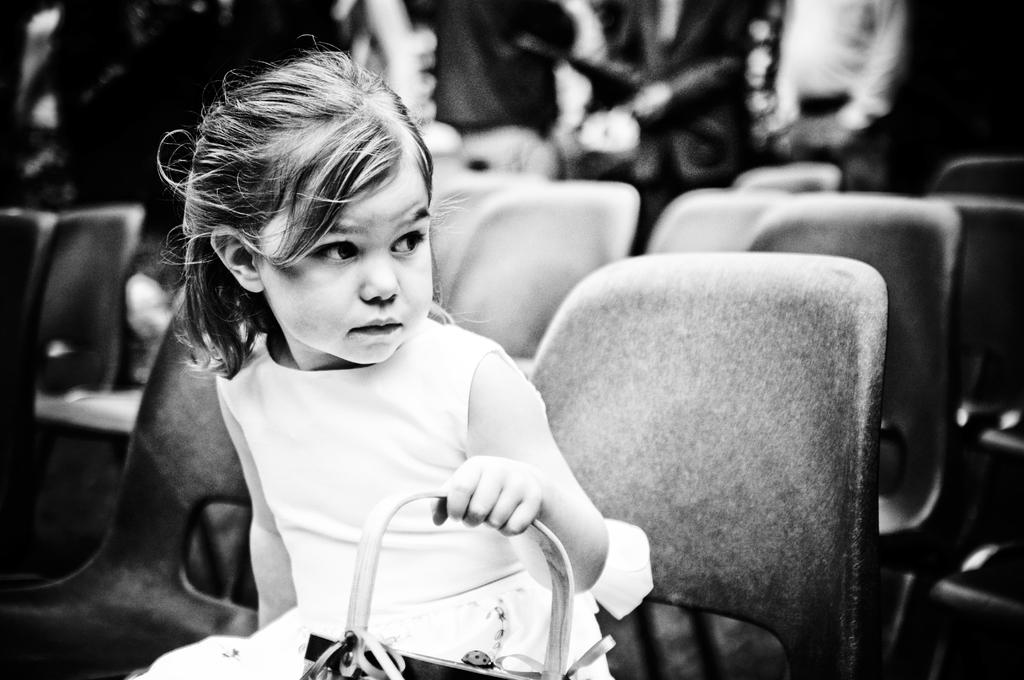Who is the main subject in the image? There is a girl in the image. What is the girl doing in the image? The girl is sitting on a chair. Are there any other chairs visible in the image? Yes, there are additional chairs visible in the background of the image. What type of crib is featured in the image? There is no crib present in the image; it features a girl sitting on a chair. What type of competition is the girl participating in within the image? There is no competition present in the image; it simply shows a girl sitting on a chair. 